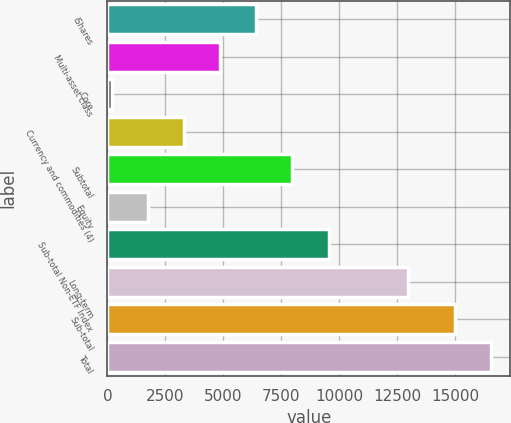Convert chart to OTSL. <chart><loc_0><loc_0><loc_500><loc_500><bar_chart><fcel>iShares<fcel>Multi-asset class<fcel>Core<fcel>Currency and commodities (4)<fcel>Subtotal<fcel>Equity<fcel>Sub-total Non-ETF Index<fcel>Long-term<fcel>Sub-total<fcel>Total<nl><fcel>6424<fcel>4870.5<fcel>210<fcel>3317<fcel>7977.5<fcel>1763.5<fcel>9531<fcel>12945<fcel>14992<fcel>16545.5<nl></chart> 